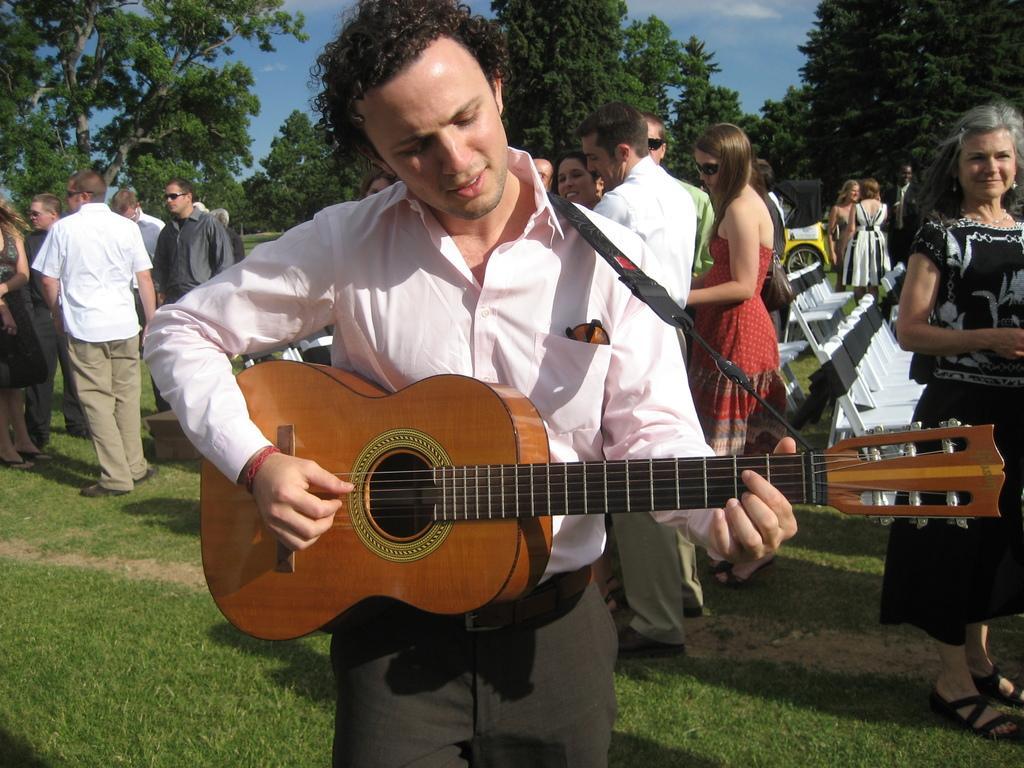In one or two sentences, can you explain what this image depicts? In this image there are group of persons standing. The person in the center is holding a musical instrument in his hand. In the background person standing and walking, there are some trees, sky, and clouds in the background. On the floor there is a grass. At the right side there are some empty chairs which is white in colour. The woman standing in black dress at the right side is having smile on her face. 